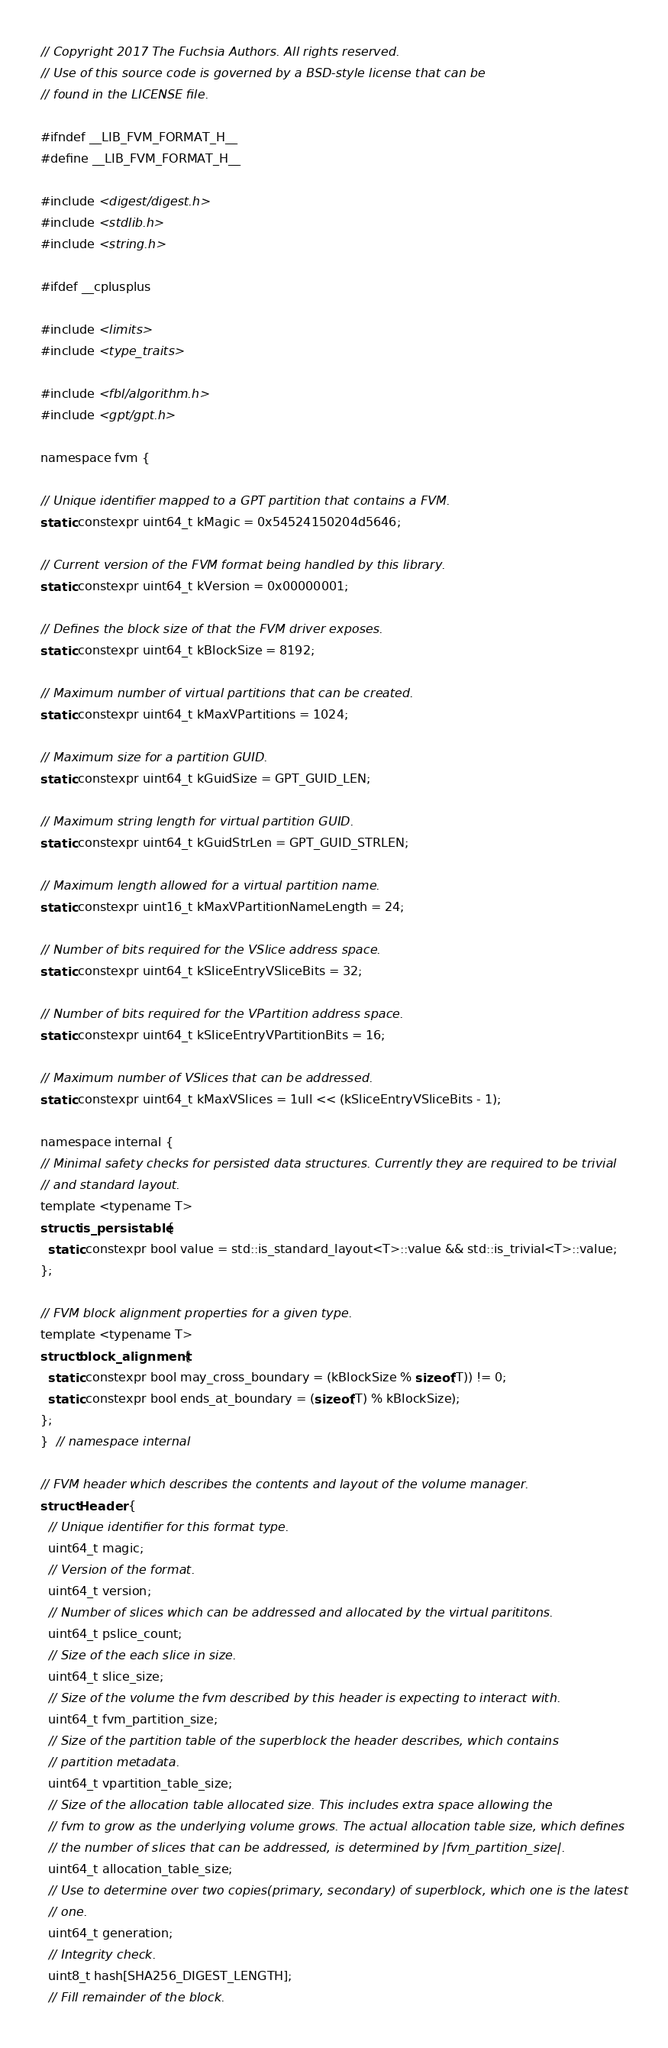<code> <loc_0><loc_0><loc_500><loc_500><_C_>// Copyright 2017 The Fuchsia Authors. All rights reserved.
// Use of this source code is governed by a BSD-style license that can be
// found in the LICENSE file.

#ifndef __LIB_FVM_FORMAT_H__
#define __LIB_FVM_FORMAT_H__

#include <digest/digest.h>
#include <stdlib.h>
#include <string.h>

#ifdef __cplusplus

#include <limits>
#include <type_traits>

#include <fbl/algorithm.h>
#include <gpt/gpt.h>

namespace fvm {

// Unique identifier mapped to a GPT partition that contains a FVM.
static constexpr uint64_t kMagic = 0x54524150204d5646;

// Current version of the FVM format being handled by this library.
static constexpr uint64_t kVersion = 0x00000001;

// Defines the block size of that the FVM driver exposes.
static constexpr uint64_t kBlockSize = 8192;

// Maximum number of virtual partitions that can be created.
static constexpr uint64_t kMaxVPartitions = 1024;

// Maximum size for a partition GUID.
static constexpr uint64_t kGuidSize = GPT_GUID_LEN;

// Maximum string length for virtual partition GUID.
static constexpr uint64_t kGuidStrLen = GPT_GUID_STRLEN;

// Maximum length allowed for a virtual partition name.
static constexpr uint16_t kMaxVPartitionNameLength = 24;

// Number of bits required for the VSlice address space.
static constexpr uint64_t kSliceEntryVSliceBits = 32;

// Number of bits required for the VPartition address space.
static constexpr uint64_t kSliceEntryVPartitionBits = 16;

// Maximum number of VSlices that can be addressed.
static constexpr uint64_t kMaxVSlices = 1ull << (kSliceEntryVSliceBits - 1);

namespace internal {
// Minimal safety checks for persisted data structures. Currently they are required to be trivial
// and standard layout.
template <typename T>
struct is_persistable {
  static constexpr bool value = std::is_standard_layout<T>::value && std::is_trivial<T>::value;
};

// FVM block alignment properties for a given type.
template <typename T>
struct block_alignment {
  static constexpr bool may_cross_boundary = (kBlockSize % sizeof(T)) != 0;
  static constexpr bool ends_at_boundary = (sizeof(T) % kBlockSize);
};
}  // namespace internal

// FVM header which describes the contents and layout of the volume manager.
struct Header {
  // Unique identifier for this format type.
  uint64_t magic;
  // Version of the format.
  uint64_t version;
  // Number of slices which can be addressed and allocated by the virtual parititons.
  uint64_t pslice_count;
  // Size of the each slice in size.
  uint64_t slice_size;
  // Size of the volume the fvm described by this header is expecting to interact with.
  uint64_t fvm_partition_size;
  // Size of the partition table of the superblock the header describes, which contains
  // partition metadata.
  uint64_t vpartition_table_size;
  // Size of the allocation table allocated size. This includes extra space allowing the
  // fvm to grow as the underlying volume grows. The actual allocation table size, which defines
  // the number of slices that can be addressed, is determined by |fvm_partition_size|.
  uint64_t allocation_table_size;
  // Use to determine over two copies(primary, secondary) of superblock, which one is the latest
  // one.
  uint64_t generation;
  // Integrity check.
  uint8_t hash[SHA256_DIGEST_LENGTH];
  // Fill remainder of the block.</code> 